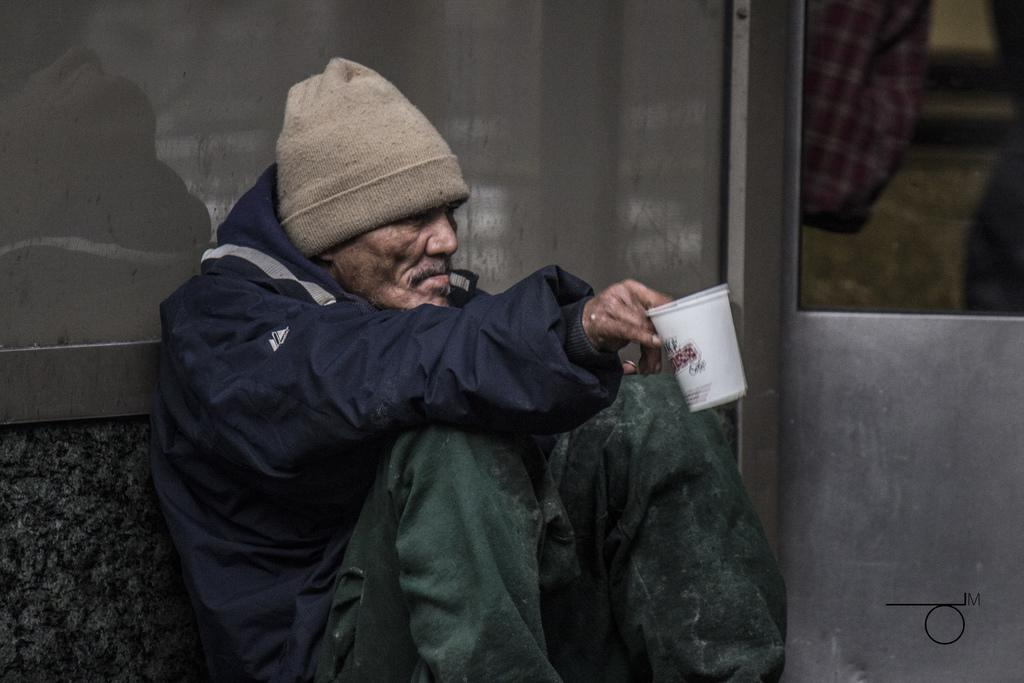Who or what is in the image? There is a person in the image. What is behind the person in the image? The person is in front of a wall. What is the person holding in the image? The person is holding a cup. What is the person wearing in the image? The person is wearing clothes and a cap. How many bikes are visible in the image? There are no bikes visible in the image; it only features a person in front of a wall holding a cup. What type of pancake is the person eating in the image? There is no pancake present in the image, and the person is not eating anything. 